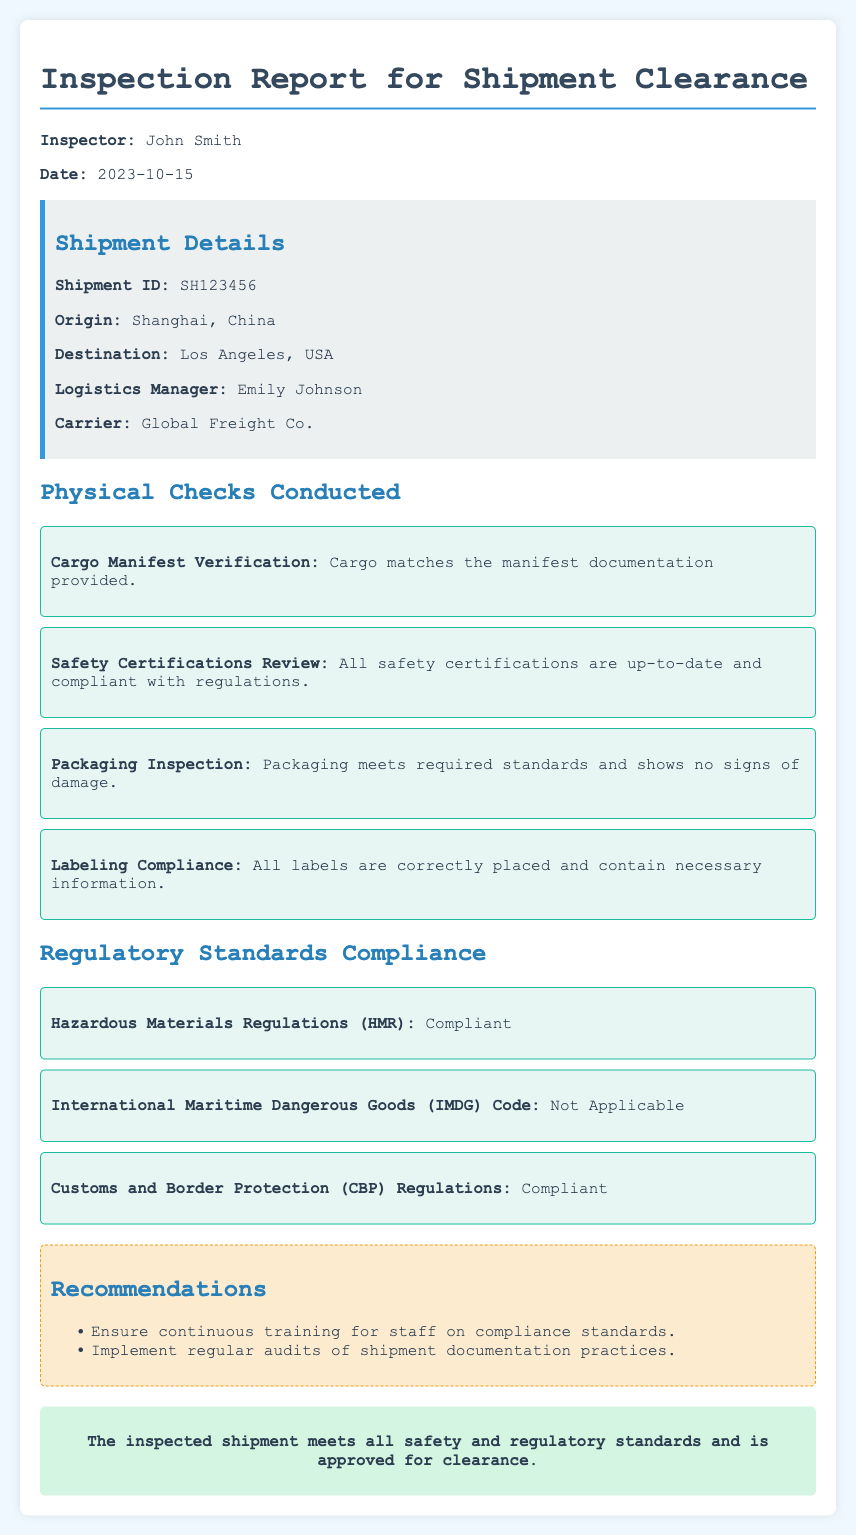What is the Shipment ID? The Shipment ID is specifically listed under 'Shipment Details' in the document.
Answer: SH123456 Who is the Inspector? The Inspector's name is mentioned at the beginning of the report.
Answer: John Smith What is the date of the inspection? The date of the inspection is stated in the document's header section.
Answer: 2023-10-15 What is the origin of the shipment? The origin is noted in the 'Shipment Details' section of the report.
Answer: Shanghai, China Is the shipment compliant with Hazardous Materials Regulations? This question requires evaluating the compliance statement in the 'Regulatory Standards Compliance' section.
Answer: Compliant What recommendations are provided in the report? Recommendations are listed under a dedicated section and summarize actions suggested for improvement.
Answer: Continuous training and regular audits How many physical checks were conducted? The number of checks can be inferred from the number of items listed in the 'Physical Checks Conducted' section.
Answer: Four What company is the carrier? The carrier's name is found in the 'Shipment Details' area of the document.
Answer: Global Freight Co What does the conclusion state about the shipment? The conclusion summarizes the overall outcome of the inspection in one statement.
Answer: Approved for clearance 